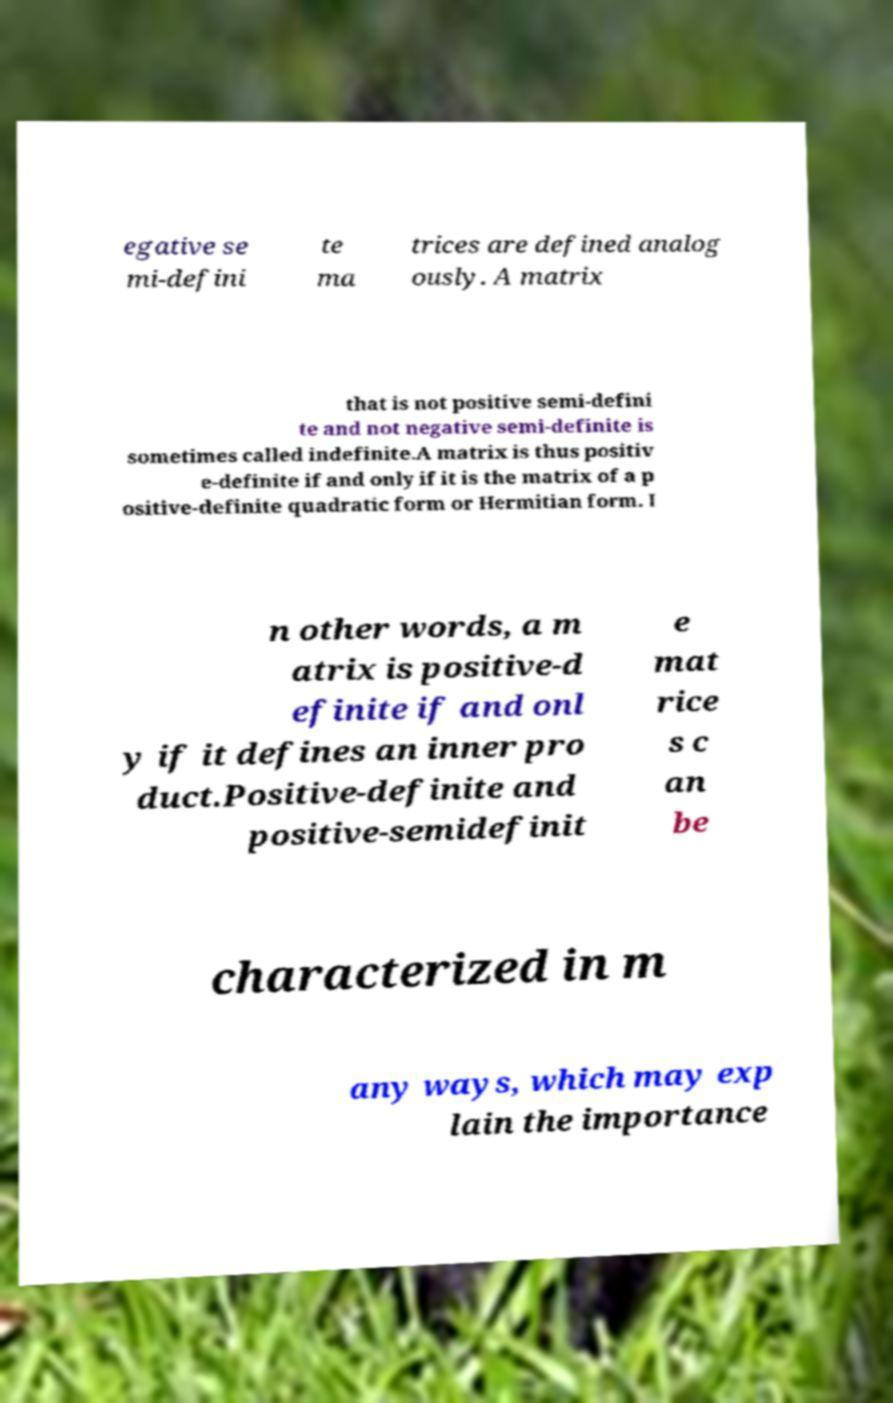For documentation purposes, I need the text within this image transcribed. Could you provide that? egative se mi-defini te ma trices are defined analog ously. A matrix that is not positive semi-defini te and not negative semi-definite is sometimes called indefinite.A matrix is thus positiv e-definite if and only if it is the matrix of a p ositive-definite quadratic form or Hermitian form. I n other words, a m atrix is positive-d efinite if and onl y if it defines an inner pro duct.Positive-definite and positive-semidefinit e mat rice s c an be characterized in m any ways, which may exp lain the importance 